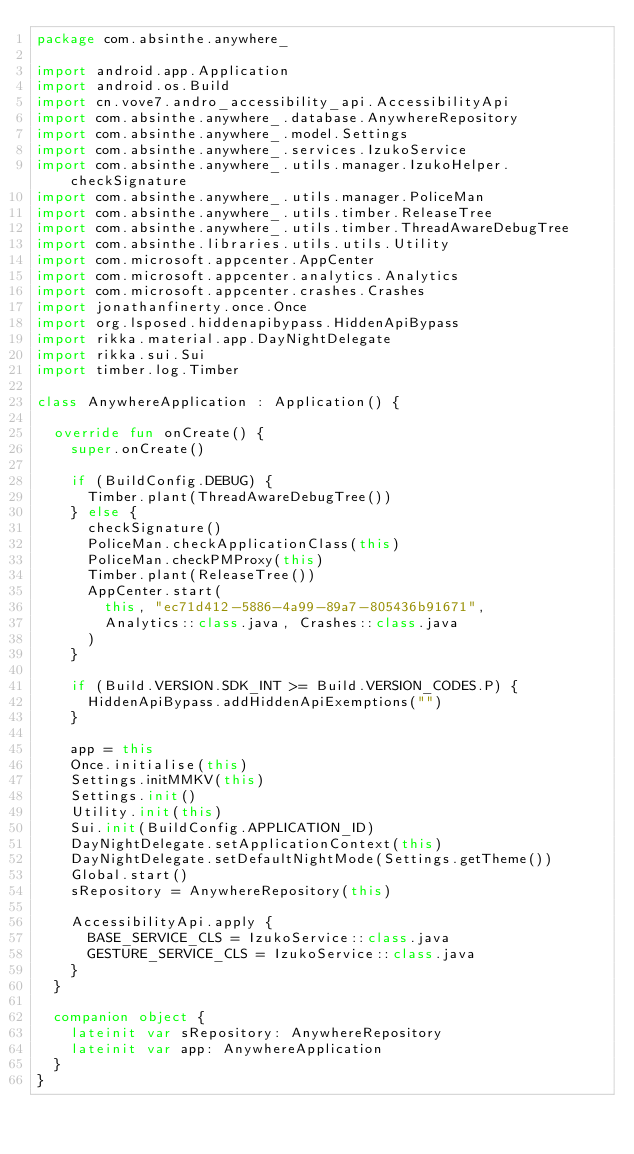<code> <loc_0><loc_0><loc_500><loc_500><_Kotlin_>package com.absinthe.anywhere_

import android.app.Application
import android.os.Build
import cn.vove7.andro_accessibility_api.AccessibilityApi
import com.absinthe.anywhere_.database.AnywhereRepository
import com.absinthe.anywhere_.model.Settings
import com.absinthe.anywhere_.services.IzukoService
import com.absinthe.anywhere_.utils.manager.IzukoHelper.checkSignature
import com.absinthe.anywhere_.utils.manager.PoliceMan
import com.absinthe.anywhere_.utils.timber.ReleaseTree
import com.absinthe.anywhere_.utils.timber.ThreadAwareDebugTree
import com.absinthe.libraries.utils.utils.Utility
import com.microsoft.appcenter.AppCenter
import com.microsoft.appcenter.analytics.Analytics
import com.microsoft.appcenter.crashes.Crashes
import jonathanfinerty.once.Once
import org.lsposed.hiddenapibypass.HiddenApiBypass
import rikka.material.app.DayNightDelegate
import rikka.sui.Sui
import timber.log.Timber

class AnywhereApplication : Application() {

  override fun onCreate() {
    super.onCreate()

    if (BuildConfig.DEBUG) {
      Timber.plant(ThreadAwareDebugTree())
    } else {
      checkSignature()
      PoliceMan.checkApplicationClass(this)
      PoliceMan.checkPMProxy(this)
      Timber.plant(ReleaseTree())
      AppCenter.start(
        this, "ec71d412-5886-4a99-89a7-805436b91671",
        Analytics::class.java, Crashes::class.java
      )
    }

    if (Build.VERSION.SDK_INT >= Build.VERSION_CODES.P) {
      HiddenApiBypass.addHiddenApiExemptions("")
    }

    app = this
    Once.initialise(this)
    Settings.initMMKV(this)
    Settings.init()
    Utility.init(this)
    Sui.init(BuildConfig.APPLICATION_ID)
    DayNightDelegate.setApplicationContext(this)
    DayNightDelegate.setDefaultNightMode(Settings.getTheme())
    Global.start()
    sRepository = AnywhereRepository(this)

    AccessibilityApi.apply {
      BASE_SERVICE_CLS = IzukoService::class.java
      GESTURE_SERVICE_CLS = IzukoService::class.java
    }
  }

  companion object {
    lateinit var sRepository: AnywhereRepository
    lateinit var app: AnywhereApplication
  }
}
</code> 